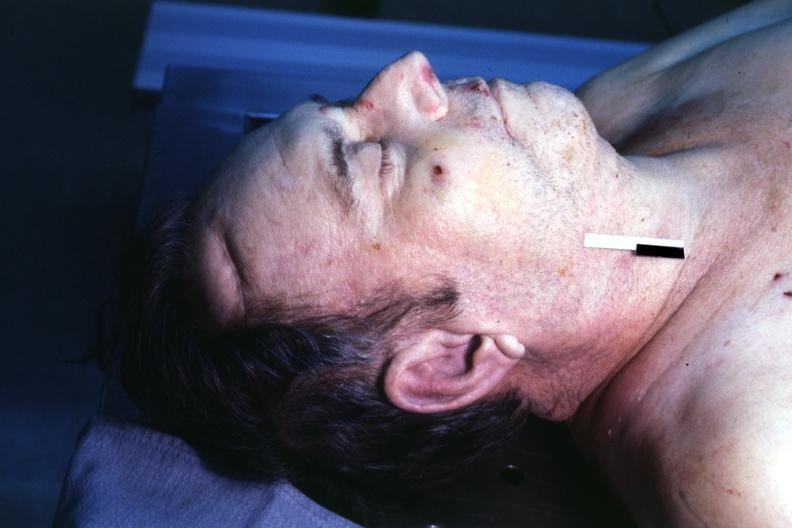s source present?
Answer the question using a single word or phrase. No 